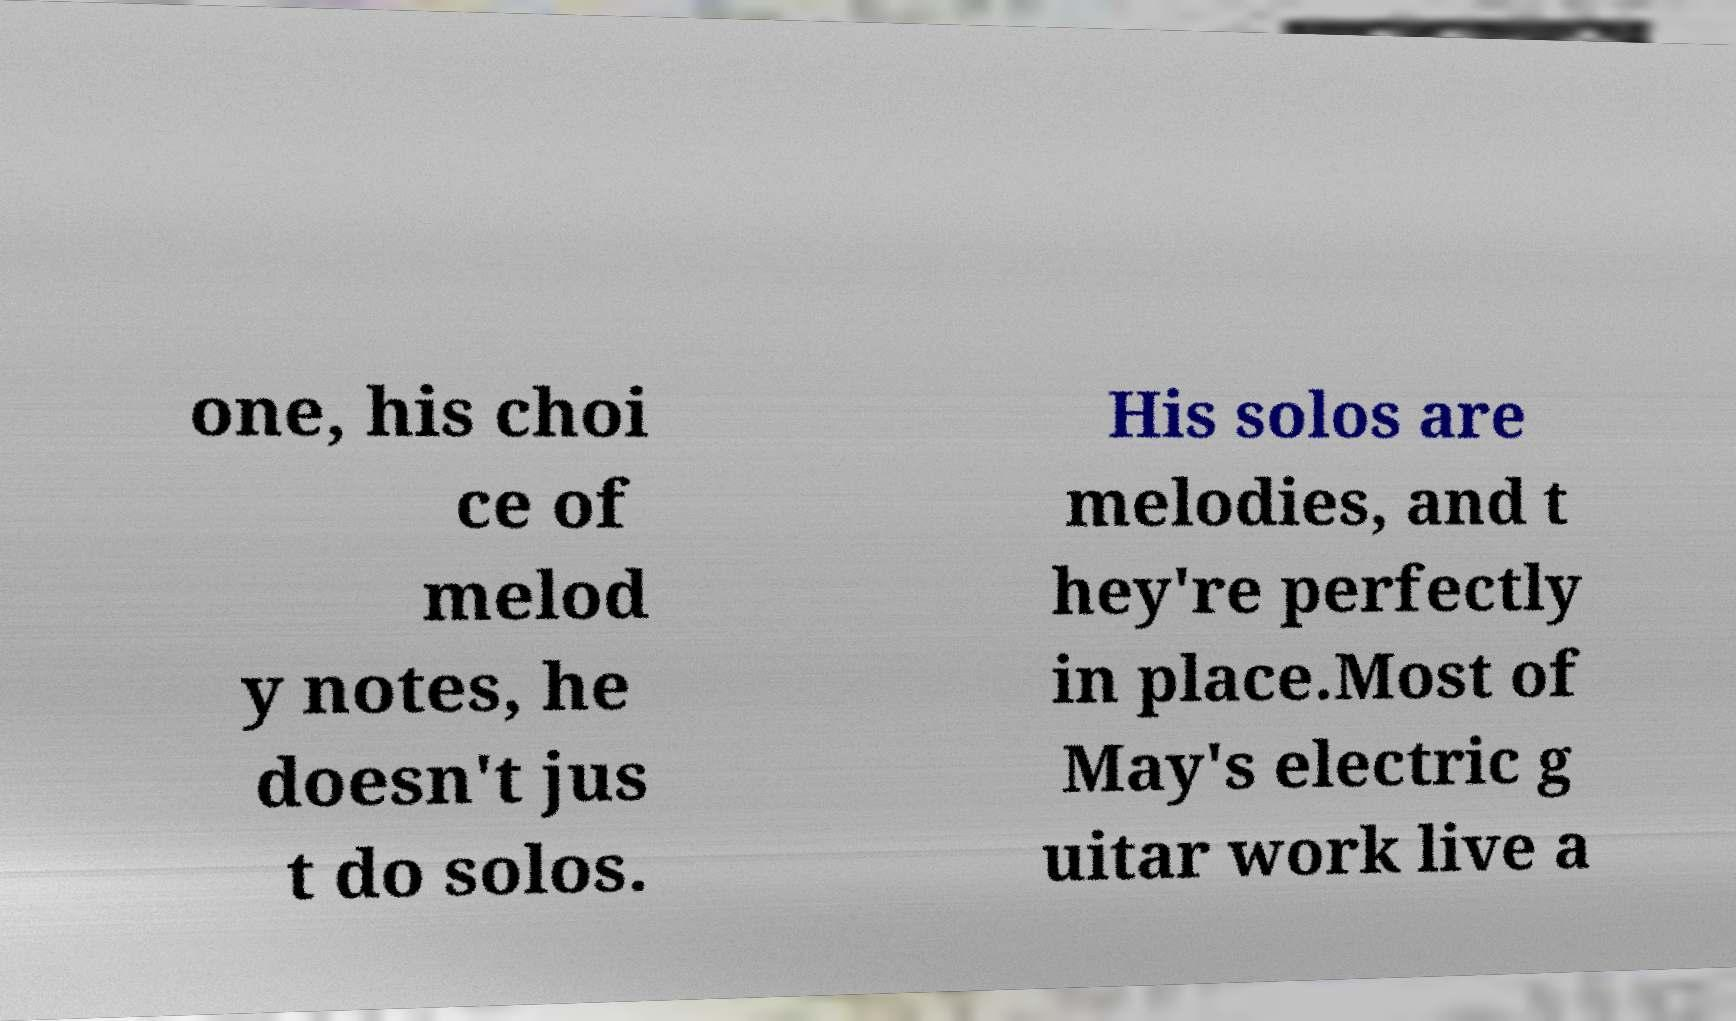Can you accurately transcribe the text from the provided image for me? one, his choi ce of melod y notes, he doesn't jus t do solos. His solos are melodies, and t hey're perfectly in place.Most of May's electric g uitar work live a 